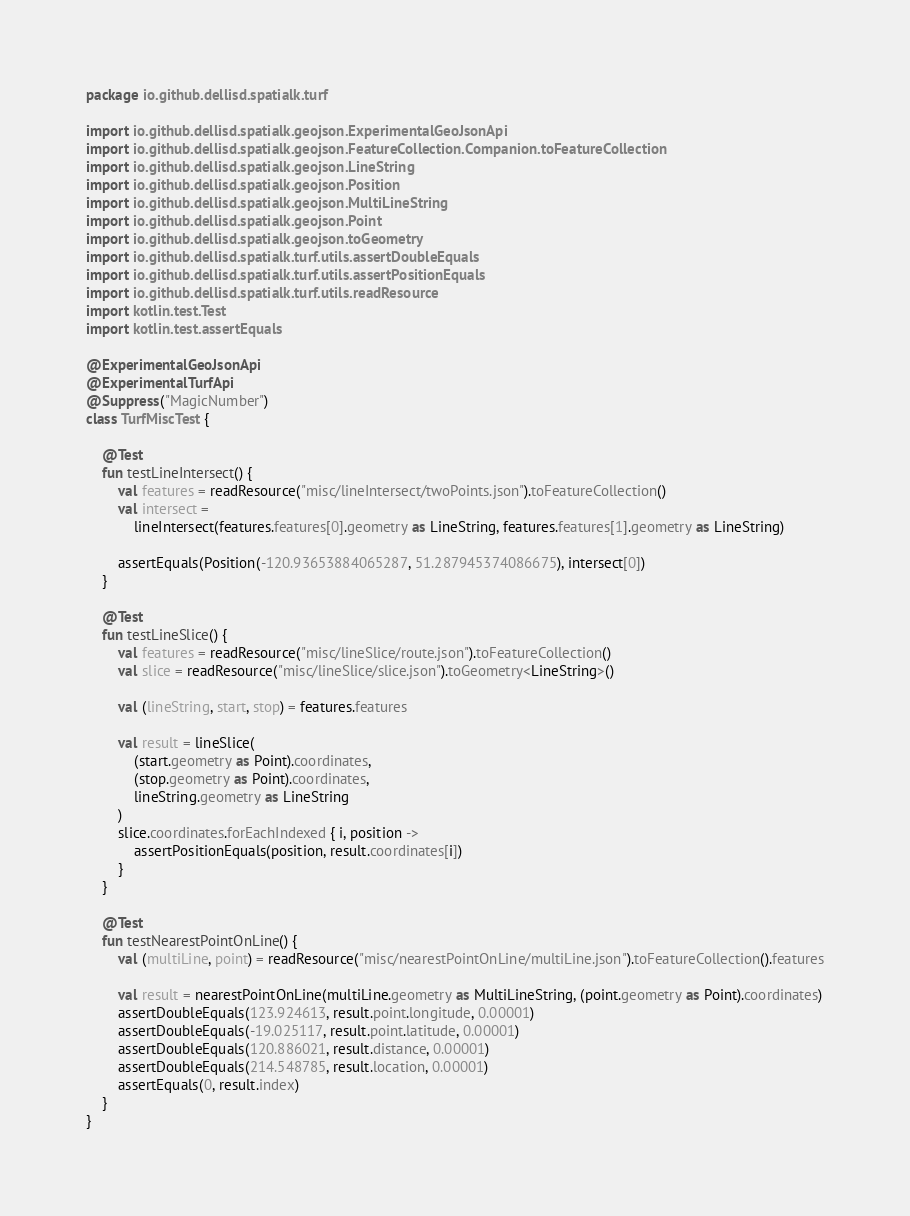Convert code to text. <code><loc_0><loc_0><loc_500><loc_500><_Kotlin_>package io.github.dellisd.spatialk.turf

import io.github.dellisd.spatialk.geojson.ExperimentalGeoJsonApi
import io.github.dellisd.spatialk.geojson.FeatureCollection.Companion.toFeatureCollection
import io.github.dellisd.spatialk.geojson.LineString
import io.github.dellisd.spatialk.geojson.Position
import io.github.dellisd.spatialk.geojson.MultiLineString
import io.github.dellisd.spatialk.geojson.Point
import io.github.dellisd.spatialk.geojson.toGeometry
import io.github.dellisd.spatialk.turf.utils.assertDoubleEquals
import io.github.dellisd.spatialk.turf.utils.assertPositionEquals
import io.github.dellisd.spatialk.turf.utils.readResource
import kotlin.test.Test
import kotlin.test.assertEquals

@ExperimentalGeoJsonApi
@ExperimentalTurfApi
@Suppress("MagicNumber")
class TurfMiscTest {

    @Test
    fun testLineIntersect() {
        val features = readResource("misc/lineIntersect/twoPoints.json").toFeatureCollection()
        val intersect =
            lineIntersect(features.features[0].geometry as LineString, features.features[1].geometry as LineString)

        assertEquals(Position(-120.93653884065287, 51.287945374086675), intersect[0])
    }

    @Test
    fun testLineSlice() {
        val features = readResource("misc/lineSlice/route.json").toFeatureCollection()
        val slice = readResource("misc/lineSlice/slice.json").toGeometry<LineString>()

        val (lineString, start, stop) = features.features

        val result = lineSlice(
            (start.geometry as Point).coordinates,
            (stop.geometry as Point).coordinates,
            lineString.geometry as LineString
        )
        slice.coordinates.forEachIndexed { i, position ->
            assertPositionEquals(position, result.coordinates[i])
        }
    }

    @Test
    fun testNearestPointOnLine() {
        val (multiLine, point) = readResource("misc/nearestPointOnLine/multiLine.json").toFeatureCollection().features

        val result = nearestPointOnLine(multiLine.geometry as MultiLineString, (point.geometry as Point).coordinates)
        assertDoubleEquals(123.924613, result.point.longitude, 0.00001)
        assertDoubleEquals(-19.025117, result.point.latitude, 0.00001)
        assertDoubleEquals(120.886021, result.distance, 0.00001)
        assertDoubleEquals(214.548785, result.location, 0.00001)
        assertEquals(0, result.index)
    }
}
</code> 